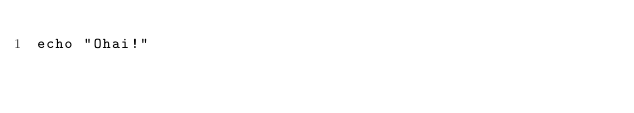Convert code to text. <code><loc_0><loc_0><loc_500><loc_500><_Nim_>echo "Ohai!"
</code> 